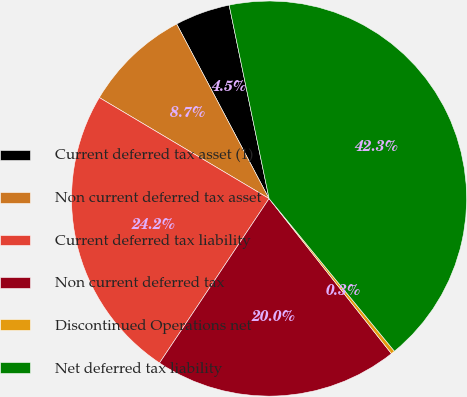<chart> <loc_0><loc_0><loc_500><loc_500><pie_chart><fcel>Current deferred tax asset (1)<fcel>Non current deferred tax asset<fcel>Current deferred tax liability<fcel>Non current deferred tax<fcel>Discontinued Operations net<fcel>Net deferred tax liability<nl><fcel>4.51%<fcel>8.71%<fcel>24.19%<fcel>19.99%<fcel>0.31%<fcel>42.3%<nl></chart> 